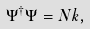Convert formula to latex. <formula><loc_0><loc_0><loc_500><loc_500>\Psi ^ { \dagger } \Psi = N k ,</formula> 